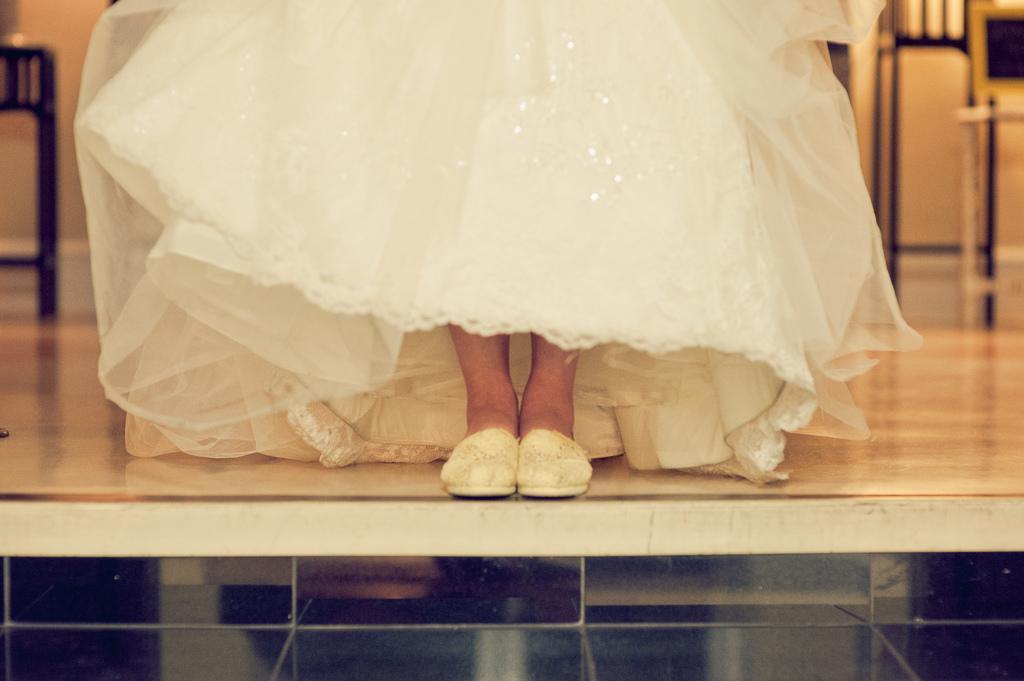How would you summarize this image in a sentence or two? A person is standing wearing a white gown and white shoes. 